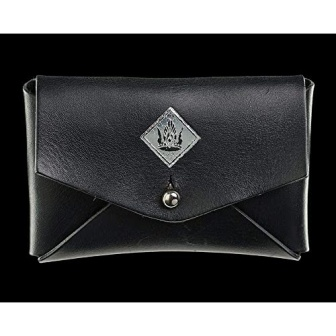What is this photo about'? The image presents a single object, a black leather wallet, resting on a black background. The wallet is closed, secured by a silver button closure. The front of the wallet is adorned with a silver emblem, which is a diamond shape featuring a crown and wings. The emblem, button closure, and the wallet itself all share the same space, creating a unified, monochromatic aesthetic. The wallet's position on the black background enhances its prominence, making it the sole focus of the image. The absence of any text or additional objects further emphasizes the wallet's solitary presence. The image does not provide any indication of movement or action, suggesting a still life composition. The relative positions of the objects remain constant, with the wallet centrally located and the emblem and button closure affixed to its surface. The image is a study in simplicity and minimalism, focusing entirely on the wallet and its details. 